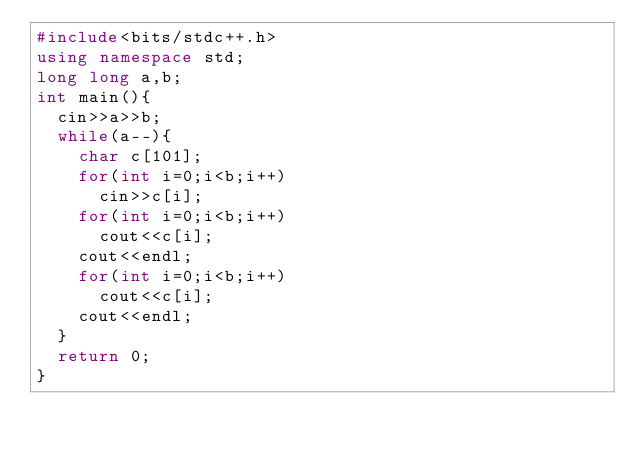<code> <loc_0><loc_0><loc_500><loc_500><_C++_>#include<bits/stdc++.h>
using namespace std;
long long a,b;
int main(){
	cin>>a>>b;
	while(a--){
		char c[101];
		for(int i=0;i<b;i++)
			cin>>c[i];
		for(int i=0;i<b;i++)
			cout<<c[i];
		cout<<endl;
		for(int i=0;i<b;i++)
			cout<<c[i];
		cout<<endl;
	}
	return 0;
}</code> 